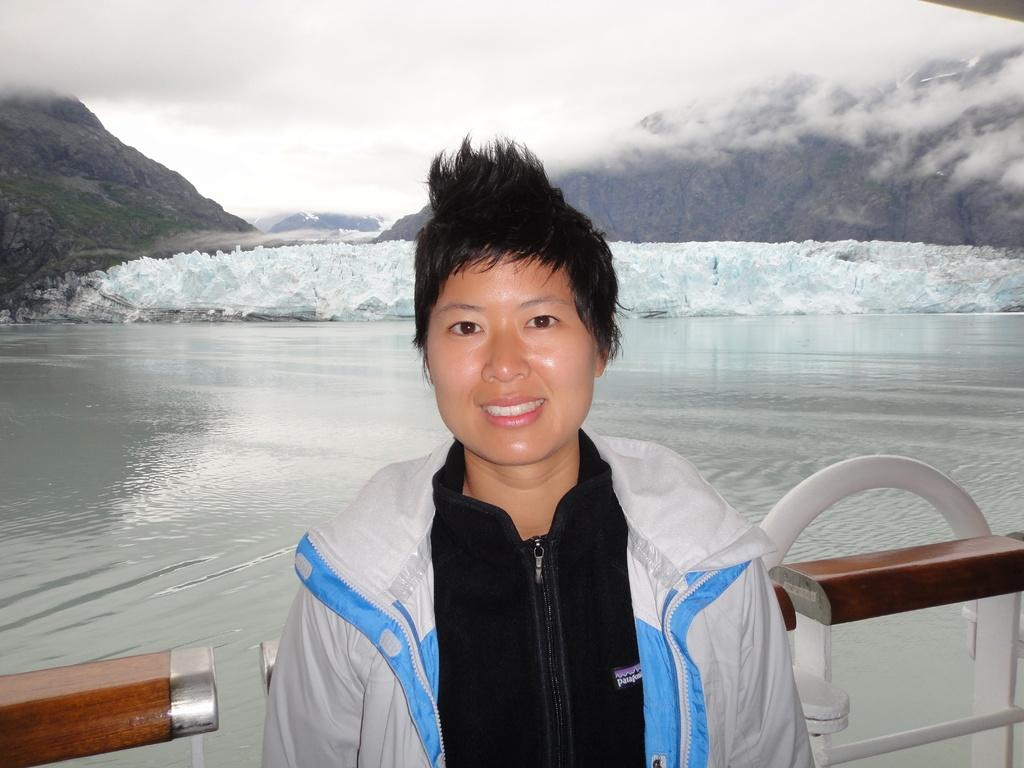Who or what is present in the image? There is a person in the image. What is the person standing near or in front of? There is a fence in the image. What can be seen in the background of the image? There is water visible in the image, as well as hills and snow. What is visible above the hills and snow? The sky is visible in the image. What type of country is depicted in the image? The image does not depict a country; it shows a person, a fence, water, hills, snow, and the sky. Are there any slaves visible in the image? There are no slaves present in the image. 